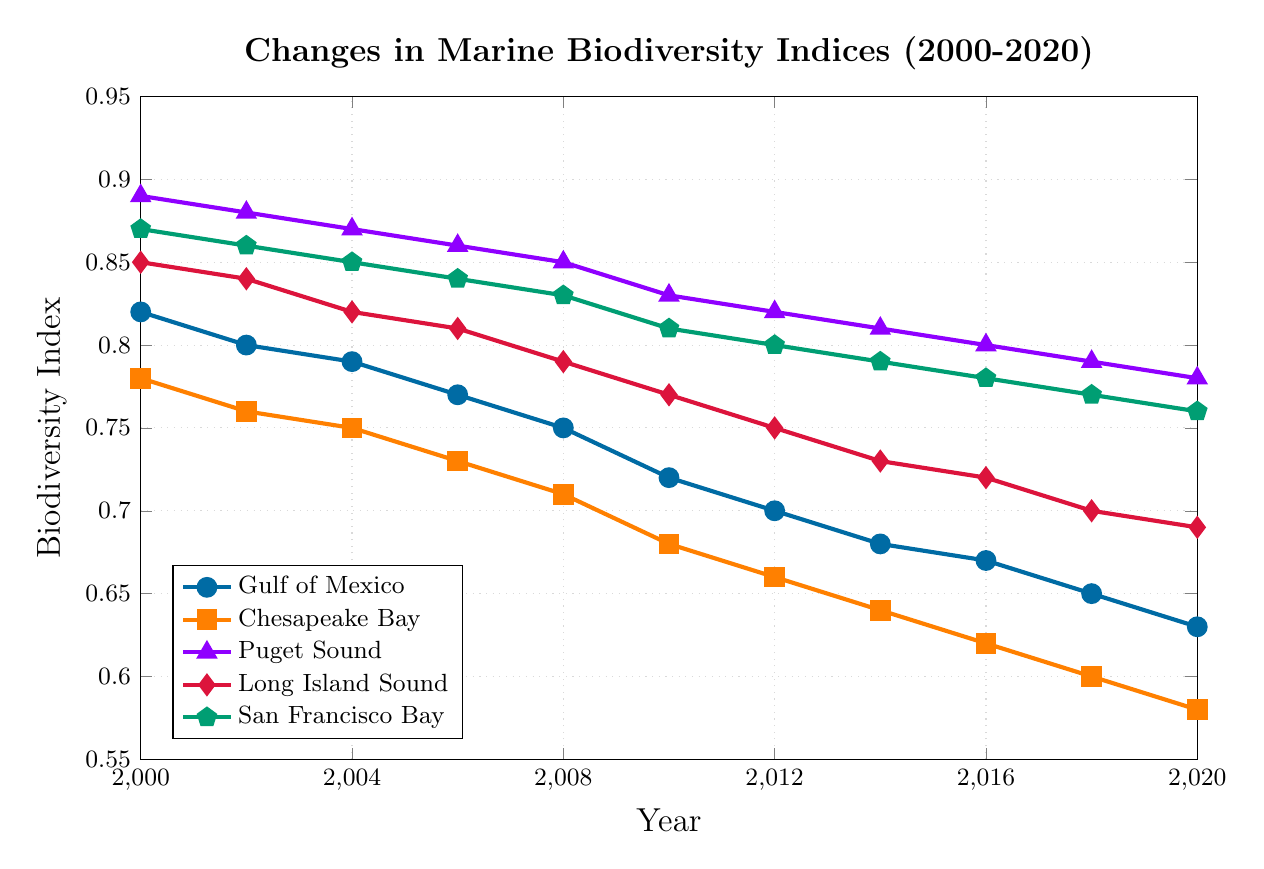What's the overall trend in the biodiversity index for the Gulf of Mexico from 2000 to 2020? The chart shows a consistent decline in the biodiversity index for the Gulf of Mexico from 2000 to 2020. The index starts at 0.82 in 2000 and gradually decreases to 0.63 in 2020, indicating a negative trend.
Answer: A consistent decline Which coastal area experienced the largest decrease in biodiversity index between 2000 and 2020? By comparing the starting and ending points of each line, Chesapeake Bay shows the largest decrease. The index dropped from 0.78 in 2000 to 0.58 in 2020, a total decrease of 0.20.
Answer: Chesapeake Bay What is the average biodiversity index for San Francisco Bay over the 20 years shown? To calculate the average, sum the indices for San Francisco Bay from each year and divide by the number of data points. Calculations: (0.87 + 0.86 + 0.85 + 0.84 + 0.83 + 0.81 + 0.80 + 0.79 + 0.78 + 0.77 + 0.76) / 11 = 8.96 / 11 = 0.8145
Answer: 0.8145 Which year showed the sharpest decline in biodiversity index for Puget Sound? Observing the line for Puget Sound, the steepest decline appears between 2006 and 2008, where the index dropped from 0.86 to 0.85. This is the most noticeable steep decline.
Answer: Between 2006 and 2008 In 2014, what is the difference in biodiversity index between Chesapeake Bay and Long Island Sound? From the 2014 data points, the biodiversity index for Chesapeake Bay is 0.64 and for Long Island Sound is 0.73. The difference is calculated as 0.73 - 0.64 = 0.09.
Answer: 0.09 How does the biodiversity index of Puget Sound in 2020 compare to its index in 2000? The biodiversity index for Puget Sound decreased from 0.89 in 2000 to 0.78 in 2020. Calculating the decrease: 0.89 - 0.78 = 0.11.
Answer: Decreased by 0.11 Between 2000 and 2020, which coastal area has shown the most stable biodiversity index? By comparing the lines for each coastal area, Puget Sound has the smallest overall change, dropping from 0.89 to 0.78, a difference of 0.11, indicating relative stability.
Answer: Puget Sound If the current trend continues, estimate the biodiversity index for the Gulf of Mexico in 2022. Observing the linear decline, we can use the trend to estimate. The index dropped by about 0.19 in 20 years, hence approximately 0.19 / 20 = 0.0095 per year. For 2 more years: 0.63 - (2 * 0.0095) = 0.610
Answer: 0.610 How many coastal areas had a biodiversity index above 0.80 in the year 2008? In 2008, referring to the y-values: Gulf of Mexico (0.75), Chesapeake Bay (0.71), Puget Sound (0.85), Long Island Sound (0.79), San Francisco Bay (0.83). Only Puget Sound and San Francisco Bay had indices above 0.80.
Answer: Two areas (Puget Sound, San Francisco Bay) What is the average biodiversity index for Long Island Sound in the first and last recorded years? For the year 2000, the index is 0.85, and for 2020, it is 0.69. The average of these values is (0.85 + 0.69) / 2 = 0.77.
Answer: 0.77 